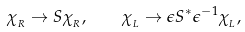<formula> <loc_0><loc_0><loc_500><loc_500>\chi _ { _ { R } } \rightarrow S \chi _ { _ { R } } , \quad \chi _ { _ { L } } \rightarrow \epsilon S ^ { * } \epsilon ^ { - 1 } \chi _ { _ { L } } ,</formula> 